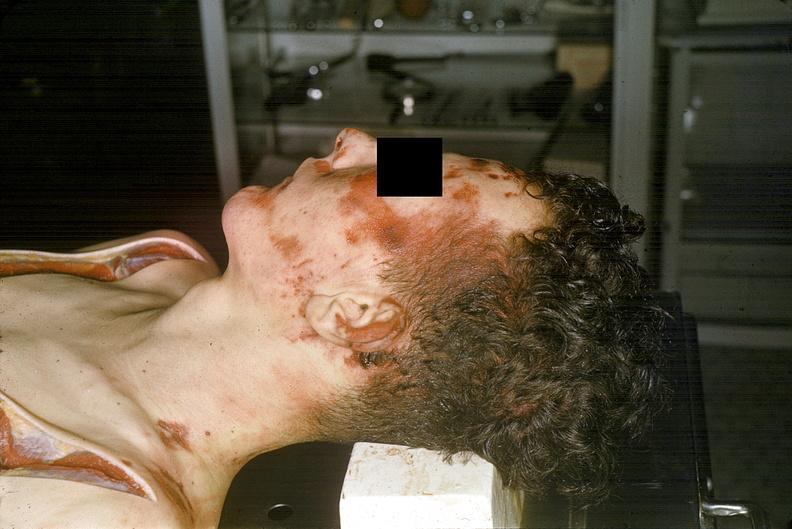what does this image show?
Answer the question using a single word or phrase. Head and face 